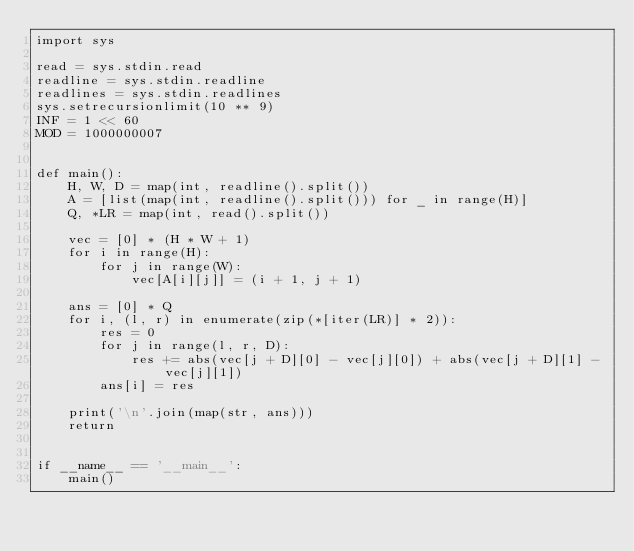Convert code to text. <code><loc_0><loc_0><loc_500><loc_500><_Python_>import sys

read = sys.stdin.read
readline = sys.stdin.readline
readlines = sys.stdin.readlines
sys.setrecursionlimit(10 ** 9)
INF = 1 << 60
MOD = 1000000007


def main():
    H, W, D = map(int, readline().split())
    A = [list(map(int, readline().split())) for _ in range(H)]
    Q, *LR = map(int, read().split())

    vec = [0] * (H * W + 1)
    for i in range(H):
        for j in range(W):
            vec[A[i][j]] = (i + 1, j + 1)

    ans = [0] * Q
    for i, (l, r) in enumerate(zip(*[iter(LR)] * 2)):
        res = 0
        for j in range(l, r, D):
            res += abs(vec[j + D][0] - vec[j][0]) + abs(vec[j + D][1] - vec[j][1])
        ans[i] = res

    print('\n'.join(map(str, ans)))
    return


if __name__ == '__main__':
    main()
</code> 